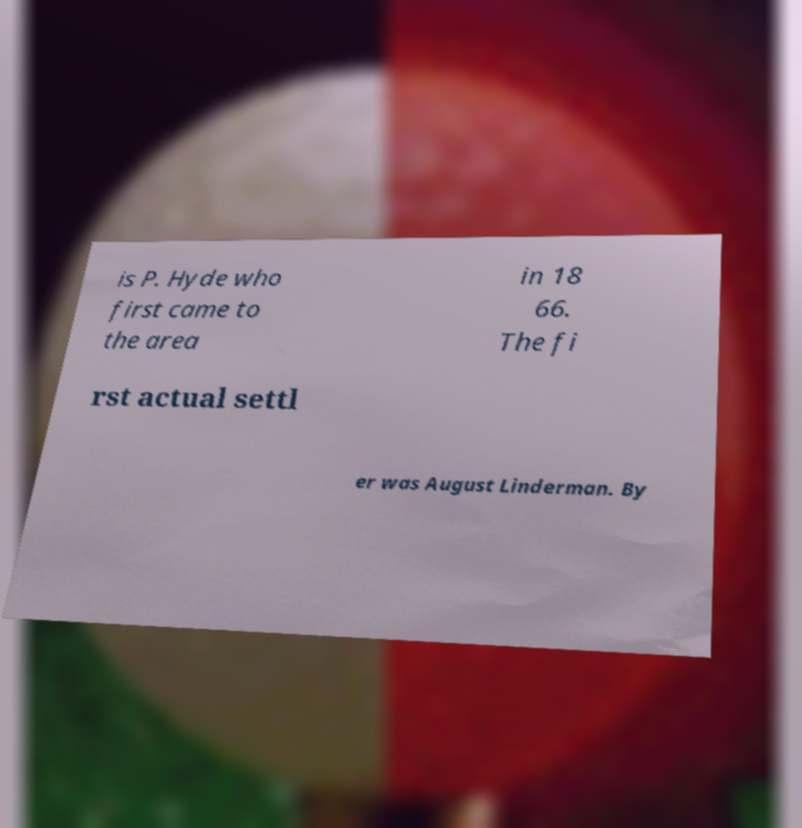I need the written content from this picture converted into text. Can you do that? is P. Hyde who first came to the area in 18 66. The fi rst actual settl er was August Linderman. By 